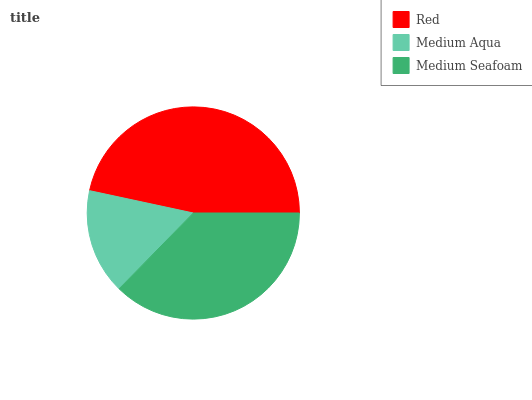Is Medium Aqua the minimum?
Answer yes or no. Yes. Is Red the maximum?
Answer yes or no. Yes. Is Medium Seafoam the minimum?
Answer yes or no. No. Is Medium Seafoam the maximum?
Answer yes or no. No. Is Medium Seafoam greater than Medium Aqua?
Answer yes or no. Yes. Is Medium Aqua less than Medium Seafoam?
Answer yes or no. Yes. Is Medium Aqua greater than Medium Seafoam?
Answer yes or no. No. Is Medium Seafoam less than Medium Aqua?
Answer yes or no. No. Is Medium Seafoam the high median?
Answer yes or no. Yes. Is Medium Seafoam the low median?
Answer yes or no. Yes. Is Medium Aqua the high median?
Answer yes or no. No. Is Red the low median?
Answer yes or no. No. 